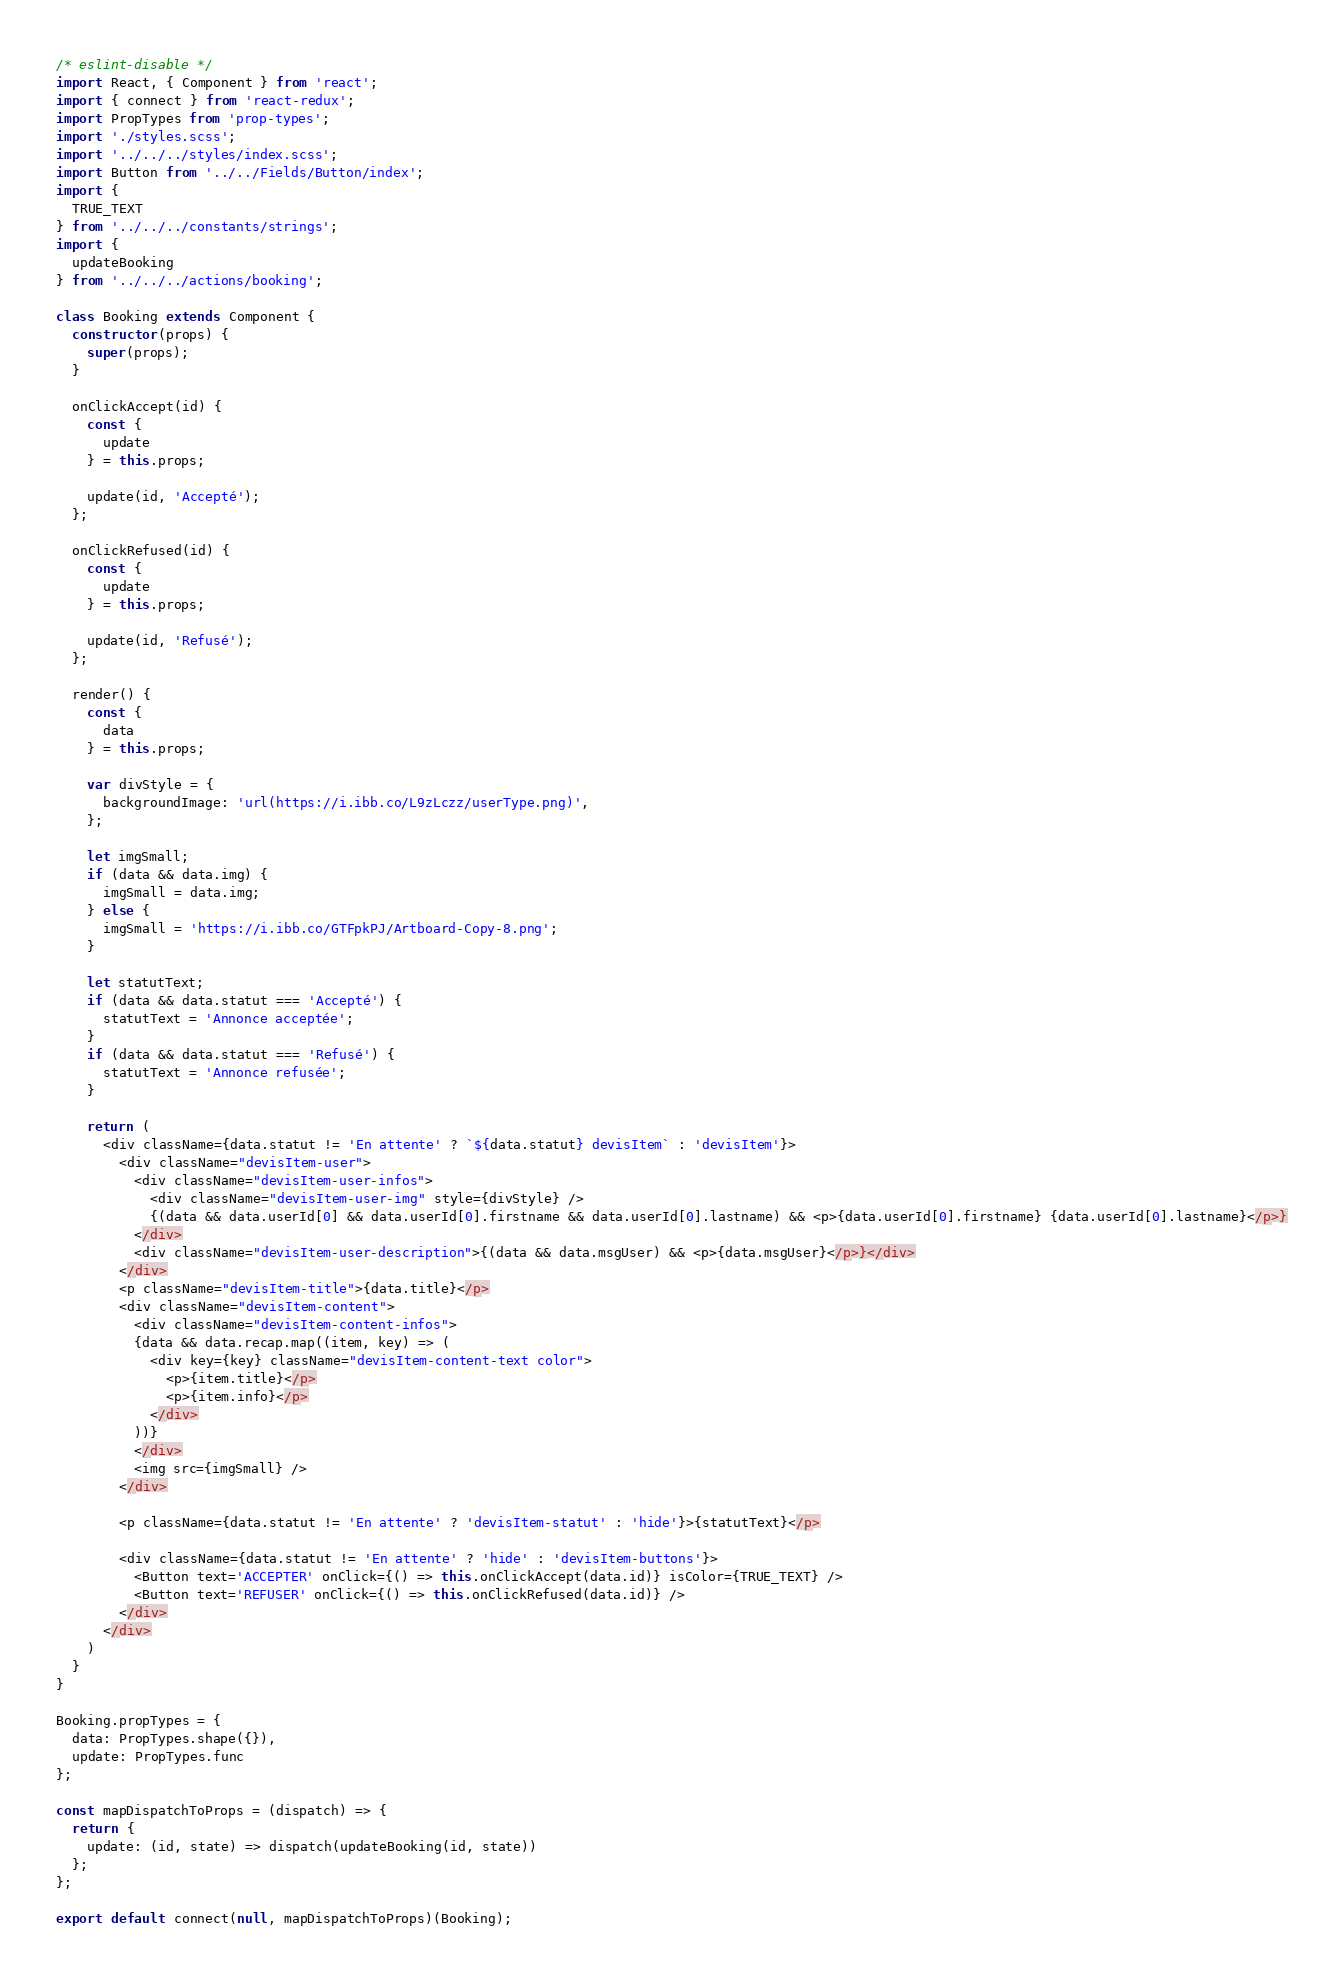<code> <loc_0><loc_0><loc_500><loc_500><_JavaScript_>/* eslint-disable */
import React, { Component } from 'react';
import { connect } from 'react-redux';
import PropTypes from 'prop-types';
import './styles.scss';
import '../../../styles/index.scss';
import Button from '../../Fields/Button/index';
import {
  TRUE_TEXT
} from '../../../constants/strings';
import {
  updateBooking
} from '../../../actions/booking';

class Booking extends Component {
  constructor(props) {
    super(props);
  }

  onClickAccept(id) {
    const {
      update
    } = this.props;

    update(id, 'Accepté');
  };

  onClickRefused(id) {
    const {
      update
    } = this.props;

    update(id, 'Refusé');
  };

  render() {
    const {
      data
    } = this.props;

    var divStyle = {
      backgroundImage: 'url(https://i.ibb.co/L9zLczz/userType.png)',
    };

    let imgSmall;
    if (data && data.img) {
      imgSmall = data.img;
    } else {
      imgSmall = 'https://i.ibb.co/GTFpkPJ/Artboard-Copy-8.png';
    }

    let statutText;
    if (data && data.statut === 'Accepté') {
      statutText = 'Annonce acceptée';
    }
    if (data && data.statut === 'Refusé') {
      statutText = 'Annonce refusée';
    }

    return (
      <div className={data.statut != 'En attente' ? `${data.statut} devisItem` : 'devisItem'}>
        <div className="devisItem-user">
          <div className="devisItem-user-infos">
            <div className="devisItem-user-img" style={divStyle} />
            {(data && data.userId[0] && data.userId[0].firstname && data.userId[0].lastname) && <p>{data.userId[0].firstname} {data.userId[0].lastname}</p>}
          </div>
          <div className="devisItem-user-description">{(data && data.msgUser) && <p>{data.msgUser}</p>}</div>
        </div>
        <p className="devisItem-title">{data.title}</p>
        <div className="devisItem-content">
          <div className="devisItem-content-infos">
          {data && data.recap.map((item, key) => (
            <div key={key} className="devisItem-content-text color">
              <p>{item.title}</p>
              <p>{item.info}</p>
            </div>
          ))}
          </div>
          <img src={imgSmall} />
        </div>

        <p className={data.statut != 'En attente' ? 'devisItem-statut' : 'hide'}>{statutText}</p>

        <div className={data.statut != 'En attente' ? 'hide' : 'devisItem-buttons'}>
          <Button text='ACCEPTER' onClick={() => this.onClickAccept(data.id)} isColor={TRUE_TEXT} />
          <Button text='REFUSER' onClick={() => this.onClickRefused(data.id)} />
        </div>
      </div>
    )
  }
}

Booking.propTypes = {
  data: PropTypes.shape({}),
  update: PropTypes.func
};

const mapDispatchToProps = (dispatch) => {
  return {
    update: (id, state) => dispatch(updateBooking(id, state))
  };
};

export default connect(null, mapDispatchToProps)(Booking);
</code> 